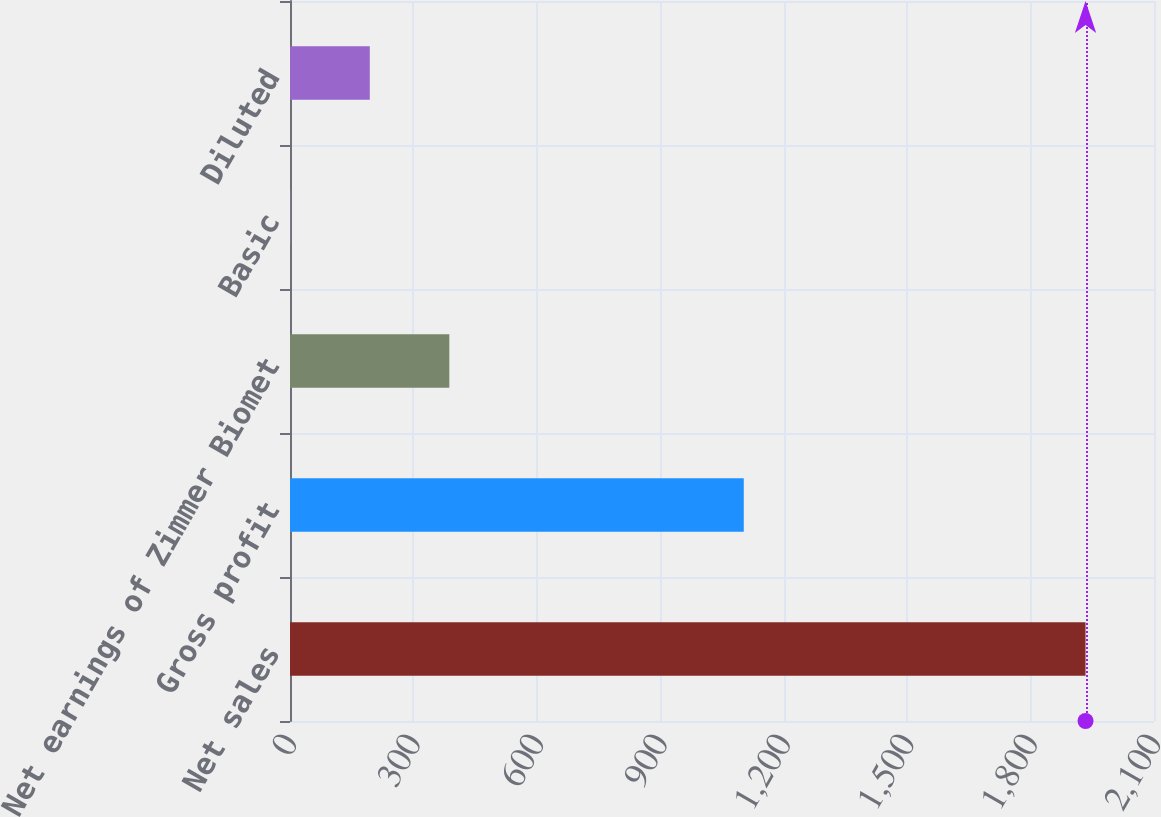Convert chart. <chart><loc_0><loc_0><loc_500><loc_500><bar_chart><fcel>Net sales<fcel>Gross profit<fcel>Net earnings of Zimmer Biomet<fcel>Basic<fcel>Diluted<nl><fcel>1933.6<fcel>1102.9<fcel>387.22<fcel>0.62<fcel>193.92<nl></chart> 